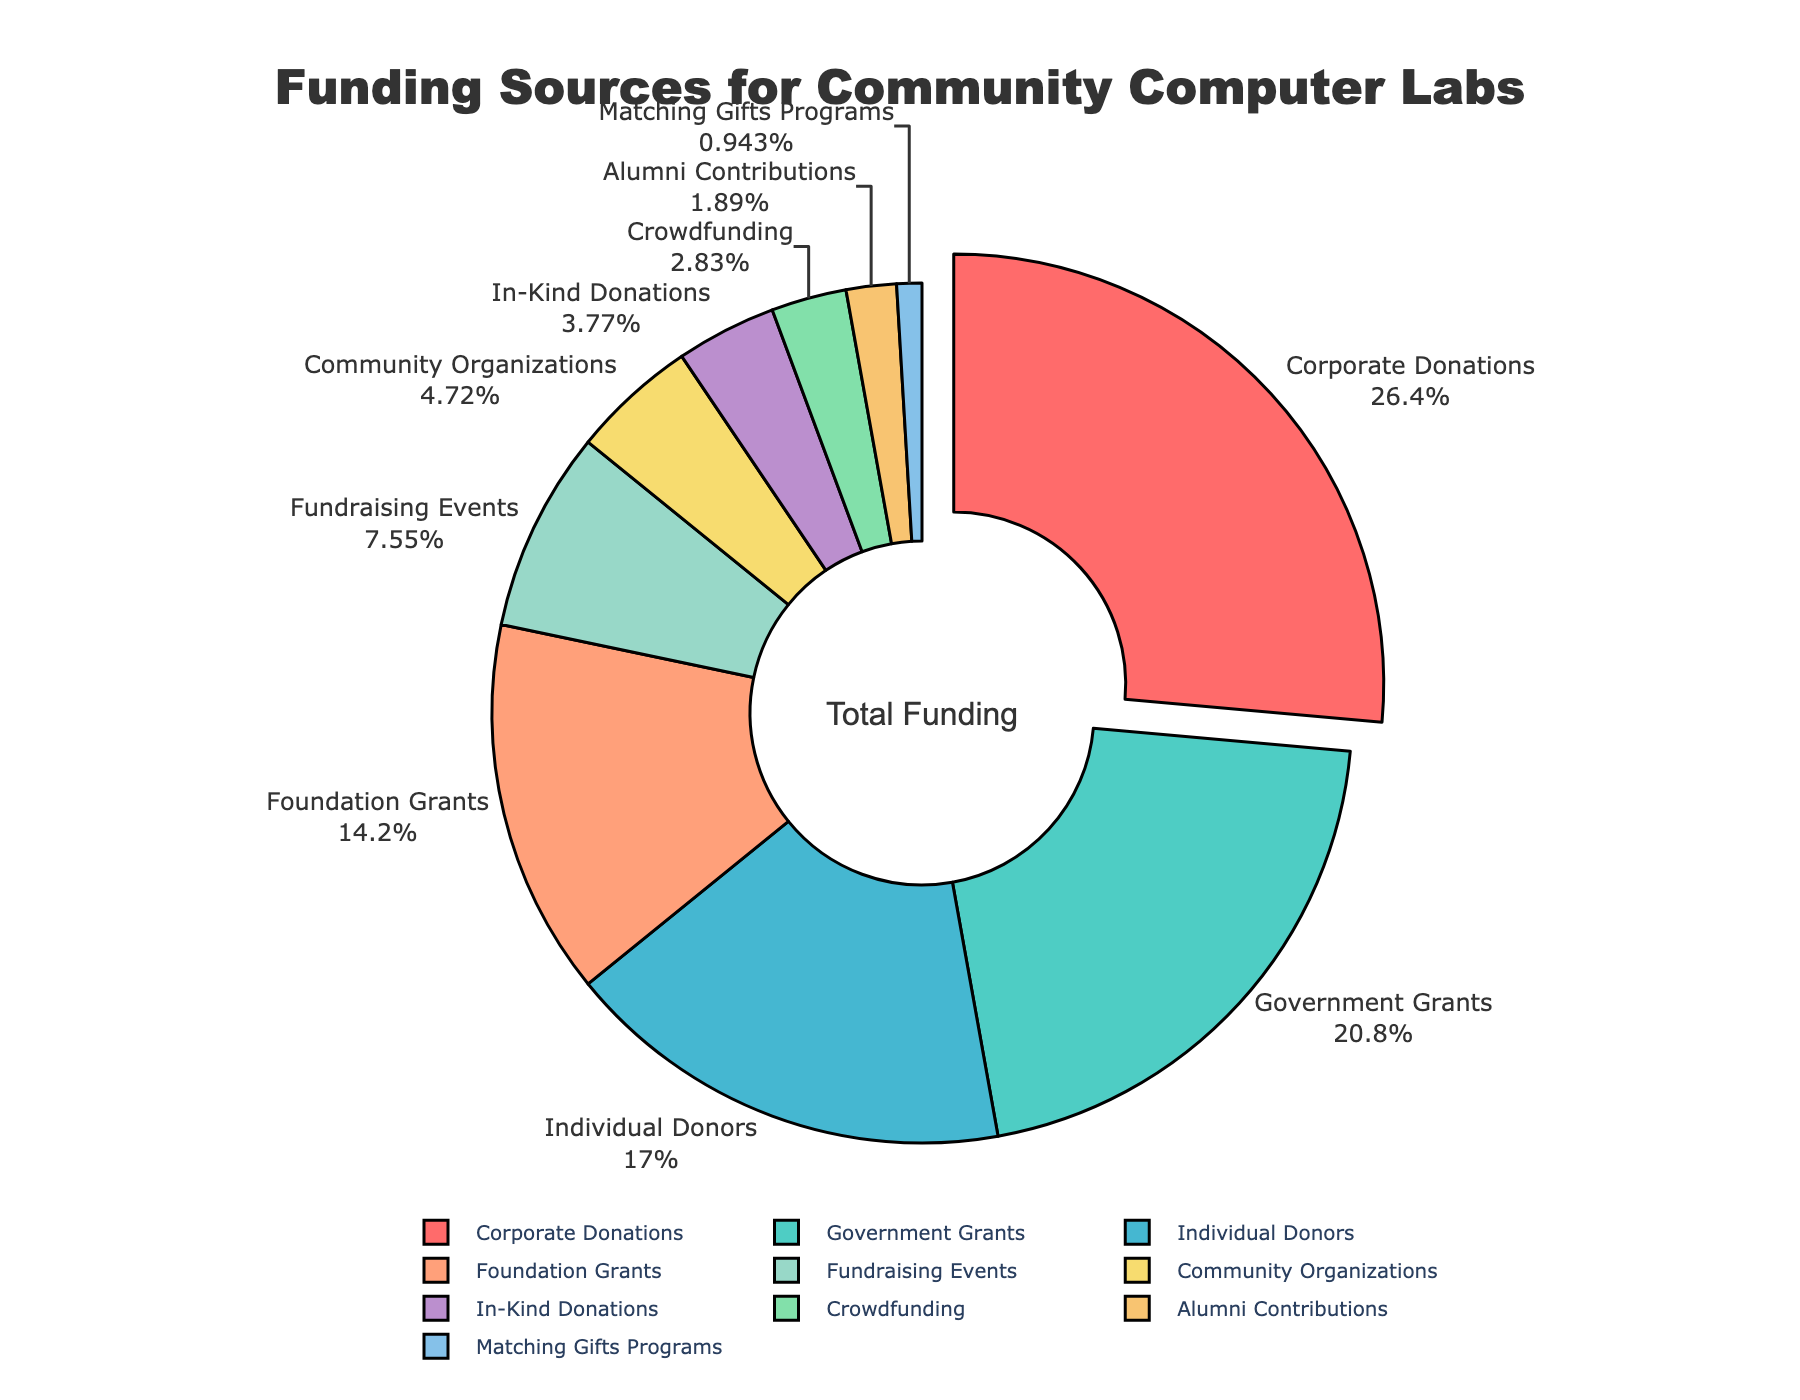What percentage of the total funding comes from individual donors and community organizations combined? Individual donors contribute 18%, and community organizations contribute 5%. Adding these, 18% + 5% = 23%.
Answer: 23% Which type of donor provides more funding: Crowdfunding or In-Kind Donations? Crowdfunding provides 3% and In-Kind Donations provide 4%. Since 4% is greater than 3%, In-Kind Donations provide more funding than Crowdfunding.
Answer: In-Kind Donations What is the difference in percentage between the highest and lowest funding sources? The highest funding source is Corporate Donations at 28%, and the lowest is Matching Gifts Programs at 1%. The difference is 28% - 1% = 27%.
Answer: 27% How much more funding do Foundation Grants provide compared to Fundraising Events? Foundation Grants provide 15% while Fundraising Events provide 8%. The difference is 15% - 8% = 7%.
Answer: 7% What percentage of the total funding is provided by the three largest donor types? The three largest donor types are Corporate Donations (28%), Government Grants (22%), and Individual Donors (18%). Adding these, 28% + 22% + 18% = 68%.
Answer: 68% Which donor category contributes more than 10% of the funding? The donor categories contributing more than 10% are Corporate Donations (28%), Government Grants (22%), Individual Donors (18%), and Foundation Grants (15%).
Answer: Corporate Donations, Government Grants, Individual Donors, Foundation Grants What percentage of the total funding comes from sources contributing less than 5% individually? Sources contributing less than 5% are Community Organizations (5%), In-Kind Donations (4%), Crowdfunding (3%), Alumni Contributions (2%), and Matching Gifts Programs (1%). Adding these, 5% + 4% + 3% + 2% + 1% = 15%.
Answer: 15% Which donor type is visually highlighted by a slight separation from the pie chart? The donor type Corporate Donations is visually highlighted by a slight separation from the pie chart.
Answer: Corporate Donations 